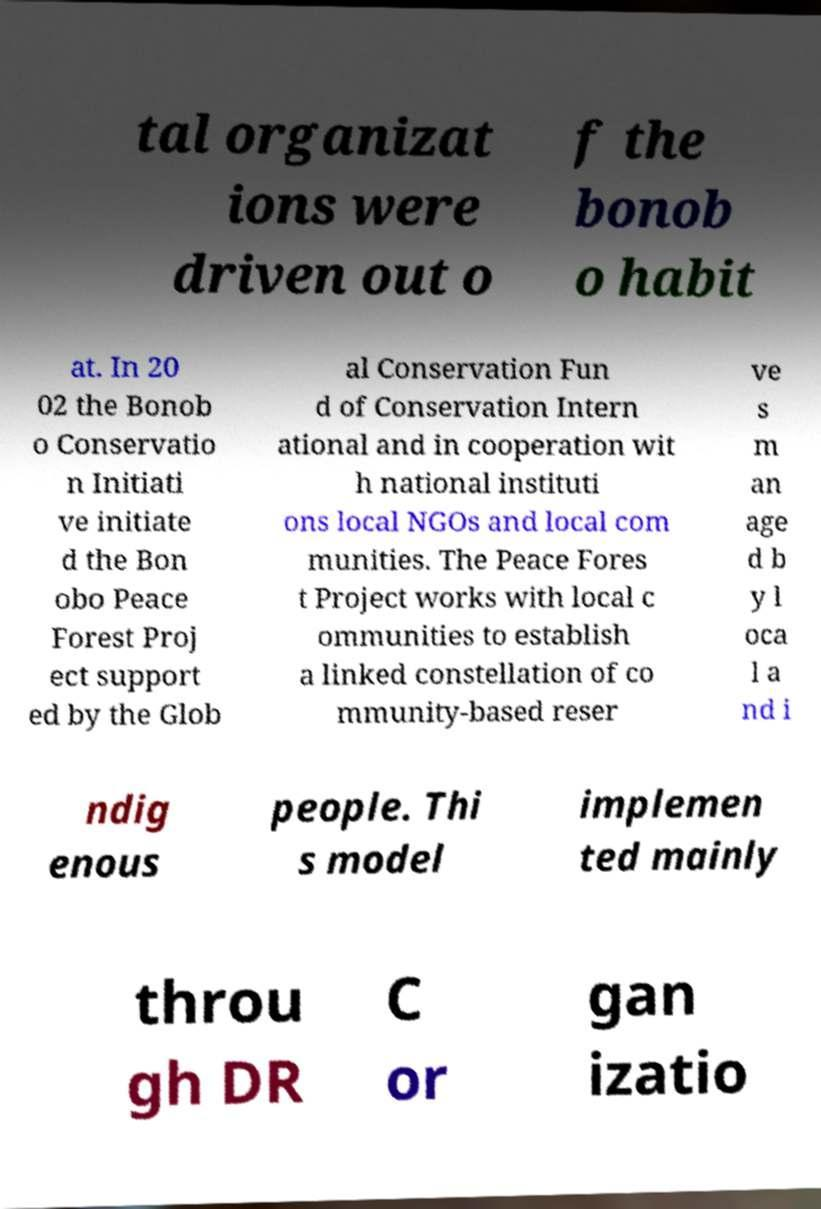Please identify and transcribe the text found in this image. tal organizat ions were driven out o f the bonob o habit at. In 20 02 the Bonob o Conservatio n Initiati ve initiate d the Bon obo Peace Forest Proj ect support ed by the Glob al Conservation Fun d of Conservation Intern ational and in cooperation wit h national instituti ons local NGOs and local com munities. The Peace Fores t Project works with local c ommunities to establish a linked constellation of co mmunity-based reser ve s m an age d b y l oca l a nd i ndig enous people. Thi s model implemen ted mainly throu gh DR C or gan izatio 